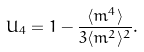<formula> <loc_0><loc_0><loc_500><loc_500>U _ { 4 } = 1 - \frac { \langle m ^ { 4 } \rangle } { 3 \langle m ^ { 2 } \rangle ^ { 2 } } .</formula> 